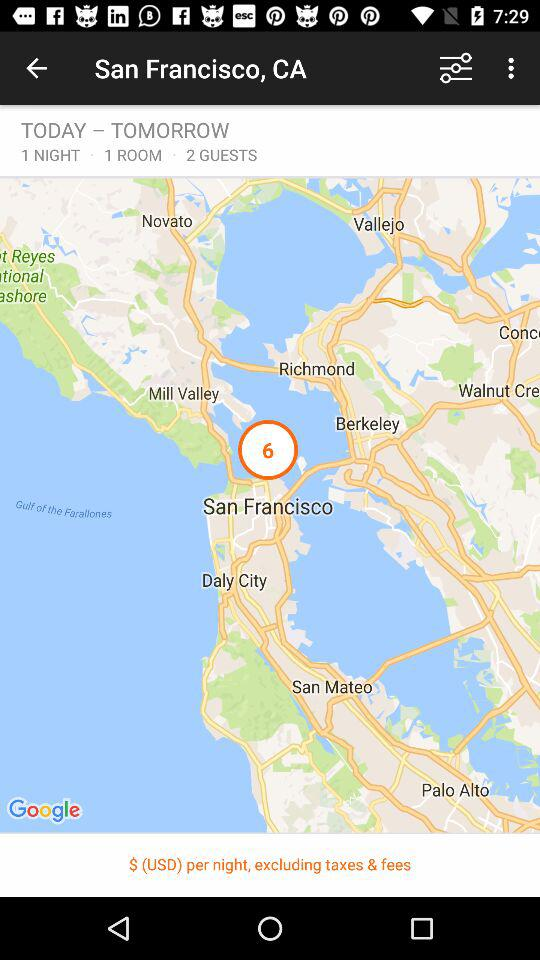Where is the hotel located?
When the provided information is insufficient, respond with <no answer>. <no answer> 